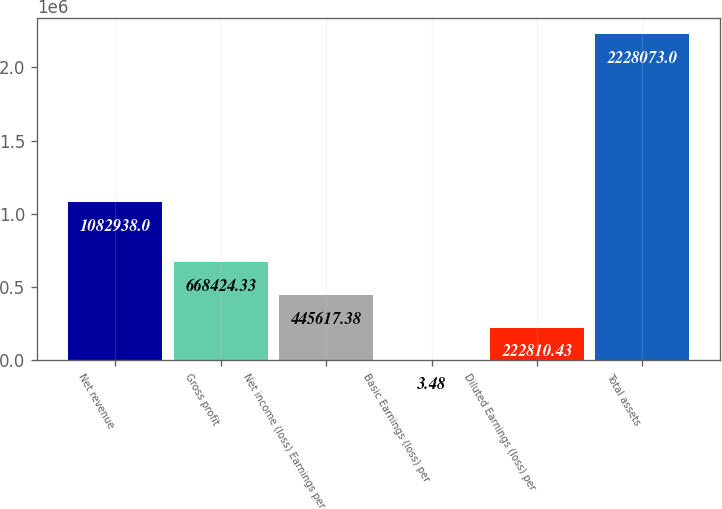<chart> <loc_0><loc_0><loc_500><loc_500><bar_chart><fcel>Net revenue<fcel>Gross profit<fcel>Net income (loss) Earnings per<fcel>Basic Earnings (loss) per<fcel>Diluted Earnings (loss) per<fcel>Total assets<nl><fcel>1.08294e+06<fcel>668424<fcel>445617<fcel>3.48<fcel>222810<fcel>2.22807e+06<nl></chart> 